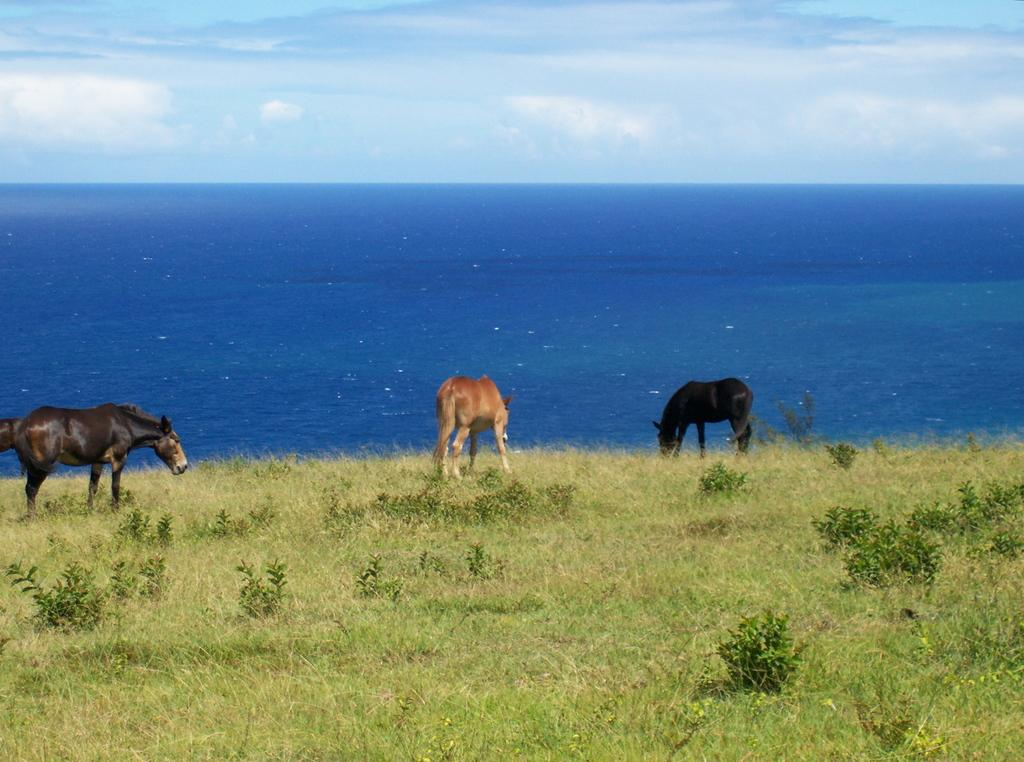What animals can be seen on the grass in the image? There are horses on the grass in the image. What type of vegetation is present on the ground? There are grasses and plants on the ground in the image. What can be seen in the background of the image? Water and the sky are visible in the background of the image. Can you see any tubs in the image? There is no tub present in the image. Are the horses' toes visible in the image? The horses' toes are not specifically mentioned or visible in the image. 